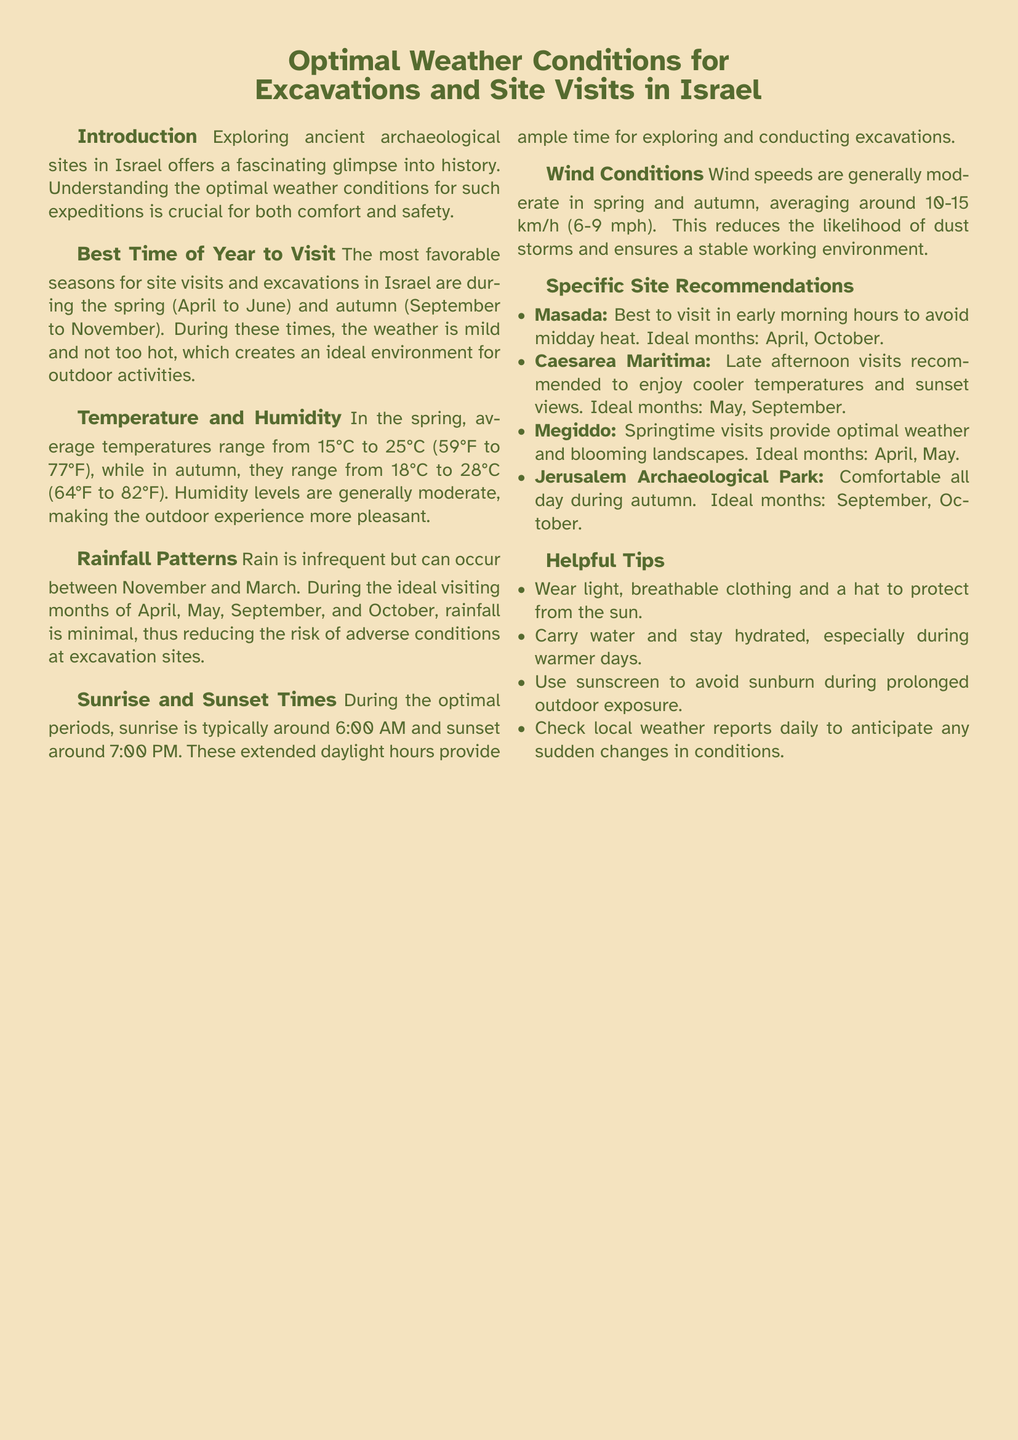What is the ideal temperature range in spring? The average temperatures in spring range from 15°C to 25°C (59°F to 77°F).
Answer: 15°C to 25°C During which months is rainfall minimal? Rainfall is minimal during the ideal visiting months of April, May, September, and October.
Answer: April, May, September, October What is the average wind speed during the optimal periods? Wind speeds during spring and autumn average around 10-15 km/h (6-9 mph).
Answer: 10-15 km/h Which site is best visited in early morning hours? The document recommends visiting Masada in the early morning hours.
Answer: Masada What are the recommended months for visiting Megiddo? The ideal months for visiting Megiddo are April and May.
Answer: April, May What attire suggestion is given for outdoor activities? The document suggests wearing light, breathable clothing and a hat to protect from the sun.
Answer: Light, breathable clothing How many hours of daylight are available during the optimal periods? Sunrise is typically around 6:00 AM and sunset around 7:00 PM during these periods.
Answer: 13 hours What is the best time to visit Caesarea Maritima? It is recommended to visit Caesarea Maritima in the late afternoon.
Answer: Late afternoon What is the humidity level during the optimal visiting seasons? Humidity levels during the optimal visiting seasons are generally moderate.
Answer: Moderate 